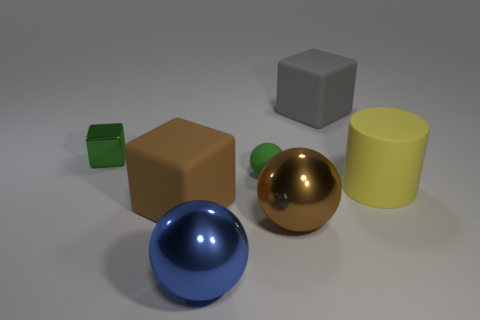What number of tiny objects are either matte cylinders or green rubber balls?
Offer a terse response. 1. Is the size of the matte object that is on the right side of the gray block the same as the gray matte object?
Your response must be concise. Yes. What number of other objects are the same color as the large matte cylinder?
Your answer should be compact. 0. What material is the cylinder?
Keep it short and to the point. Rubber. What material is the ball that is behind the large blue shiny thing and on the left side of the large brown ball?
Keep it short and to the point. Rubber. What number of objects are either big rubber things on the left side of the large gray rubber object or large cylinders?
Make the answer very short. 2. Does the small sphere have the same color as the metallic block?
Your answer should be very brief. Yes. Are there any gray matte balls that have the same size as the green sphere?
Provide a short and direct response. No. How many things are both in front of the rubber cylinder and behind the brown block?
Give a very brief answer. 0. What number of large gray objects are on the left side of the brown block?
Offer a terse response. 0. 